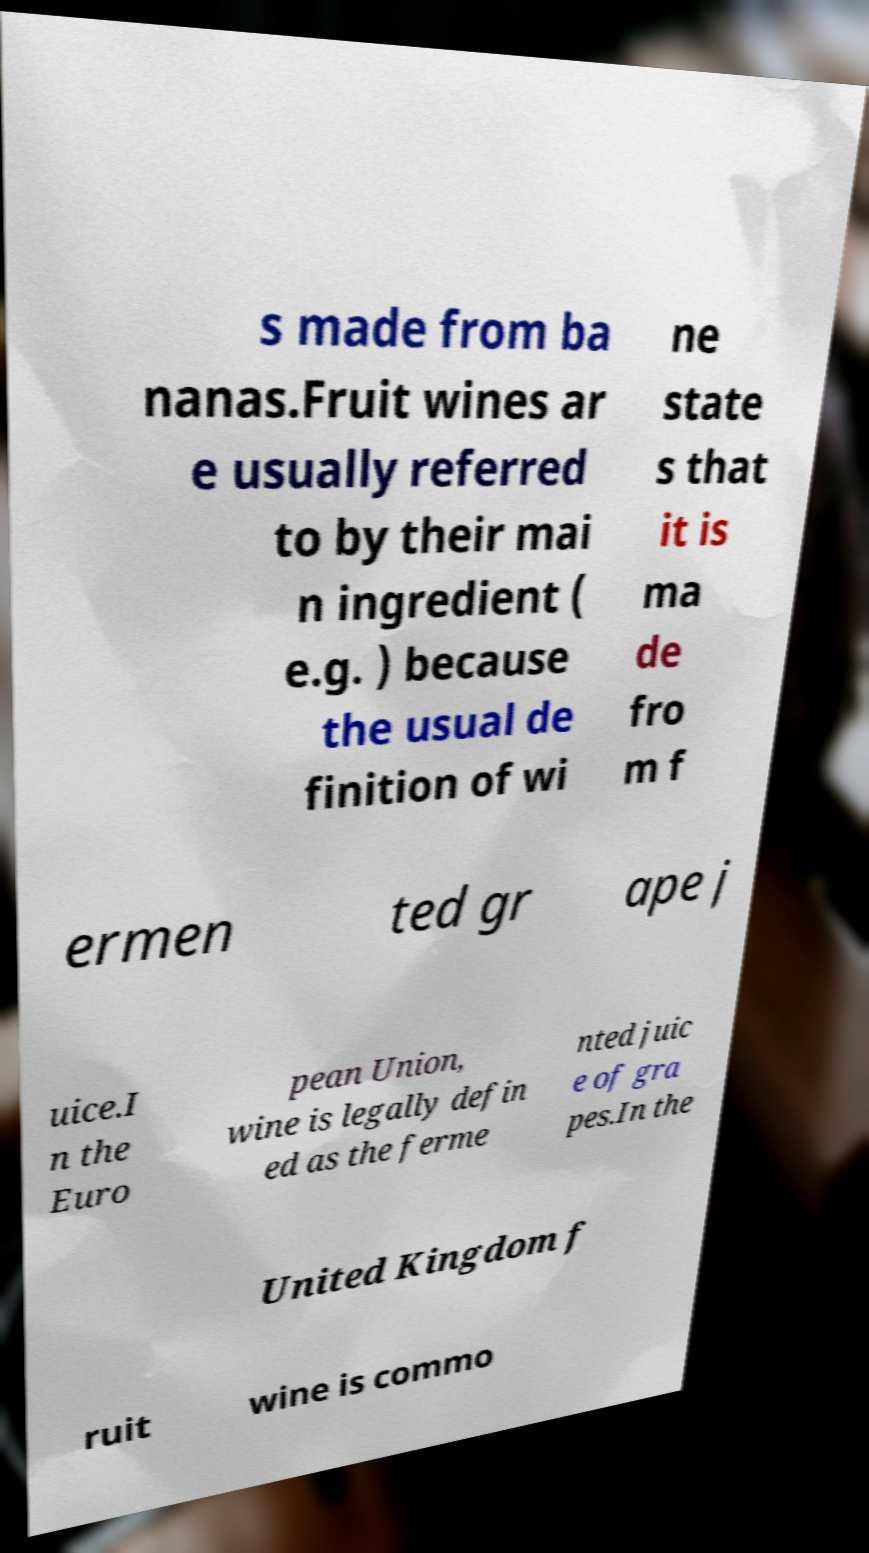For documentation purposes, I need the text within this image transcribed. Could you provide that? s made from ba nanas.Fruit wines ar e usually referred to by their mai n ingredient ( e.g. ) because the usual de finition of wi ne state s that it is ma de fro m f ermen ted gr ape j uice.I n the Euro pean Union, wine is legally defin ed as the ferme nted juic e of gra pes.In the United Kingdom f ruit wine is commo 